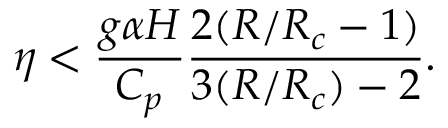Convert formula to latex. <formula><loc_0><loc_0><loc_500><loc_500>\eta < \frac { g \alpha H } { C _ { p } } { \frac { 2 ( R / R _ { c } - 1 ) } { 3 ( R / R _ { c } ) - 2 } } .</formula> 